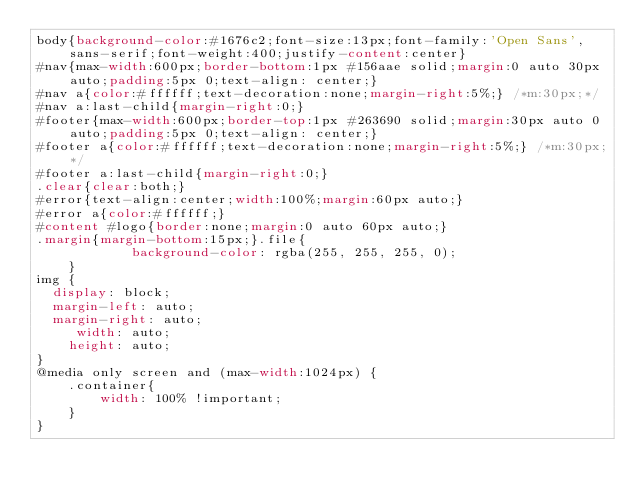<code> <loc_0><loc_0><loc_500><loc_500><_CSS_>body{background-color:#1676c2;font-size:13px;font-family:'Open Sans', sans-serif;font-weight:400;justify-content:center}
#nav{max-width:600px;border-bottom:1px #156aae solid;margin:0 auto 30px auto;padding:5px 0;text-align: center;}
#nav a{color:#ffffff;text-decoration:none;margin-right:5%;} /*m:30px;*/
#nav a:last-child{margin-right:0;}
#footer{max-width:600px;border-top:1px #263690 solid;margin:30px auto 0 auto;padding:5px 0;text-align: center;}
#footer a{color:#ffffff;text-decoration:none;margin-right:5%;} /*m:30px;*/
#footer a:last-child{margin-right:0;}
.clear{clear:both;}
#error{text-align:center;width:100%;margin:60px auto;}
#error a{color:#ffffff;}
#content #logo{border:none;margin:0 auto 60px auto;}
.margin{margin-bottom:15px;}.file{
    	    background-color: rgba(255, 255, 255, 0);
    }
img {
  display: block;
  margin-left: auto;
  margin-right: auto;
     width: auto;
    height: auto;
}
@media only screen and (max-width:1024px) {
	.container{
		width: 100% !important;
	}
}
</code> 